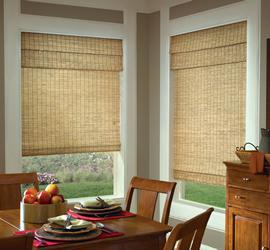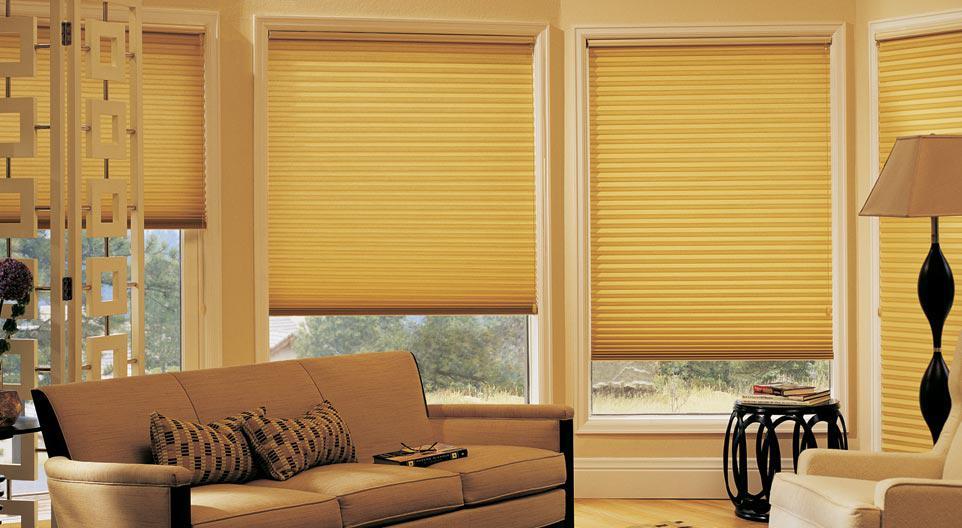The first image is the image on the left, the second image is the image on the right. Evaluate the accuracy of this statement regarding the images: "There are exactly three shades in the right image.". Is it true? Answer yes or no. No. The first image is the image on the left, the second image is the image on the right. Evaluate the accuracy of this statement regarding the images: "There are eight blinds.". Is it true? Answer yes or no. No. 